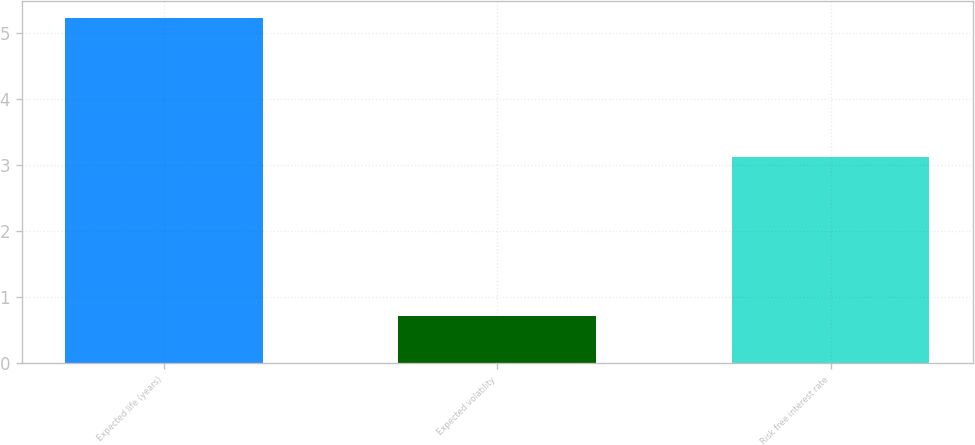Convert chart to OTSL. <chart><loc_0><loc_0><loc_500><loc_500><bar_chart><fcel>Expected life (years)<fcel>Expected volatility<fcel>Risk free interest rate<nl><fcel>5.23<fcel>0.72<fcel>3.12<nl></chart> 